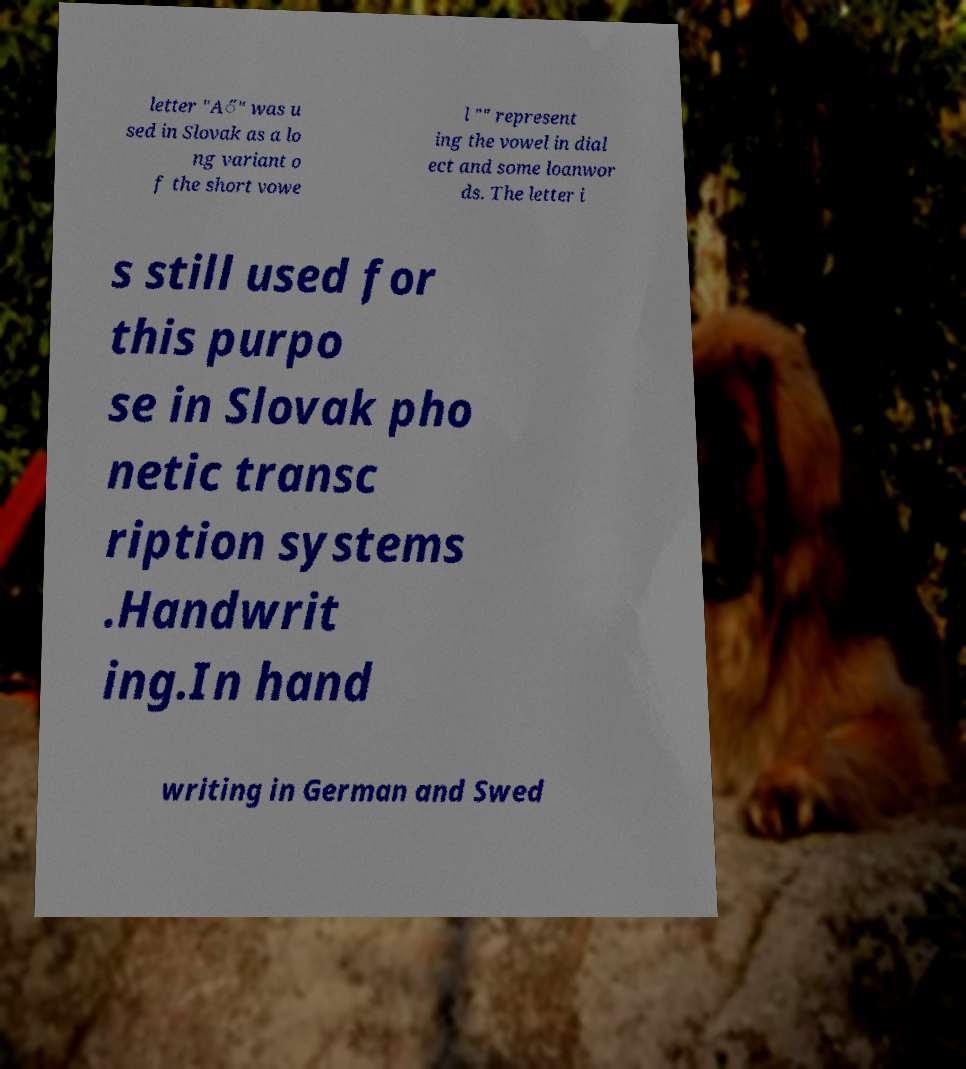I need the written content from this picture converted into text. Can you do that? letter "A̋" was u sed in Slovak as a lo ng variant o f the short vowe l "" represent ing the vowel in dial ect and some loanwor ds. The letter i s still used for this purpo se in Slovak pho netic transc ription systems .Handwrit ing.In hand writing in German and Swed 